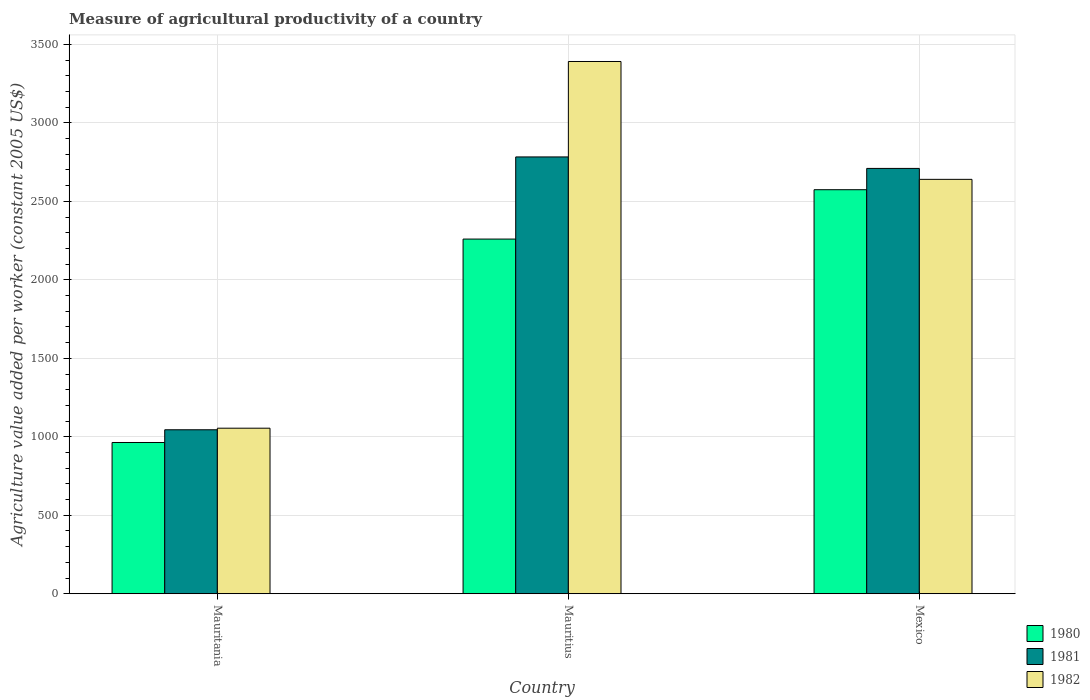How many different coloured bars are there?
Provide a short and direct response. 3. How many groups of bars are there?
Provide a short and direct response. 3. Are the number of bars per tick equal to the number of legend labels?
Your answer should be compact. Yes. What is the label of the 1st group of bars from the left?
Provide a short and direct response. Mauritania. What is the measure of agricultural productivity in 1982 in Mauritania?
Offer a very short reply. 1054.73. Across all countries, what is the maximum measure of agricultural productivity in 1981?
Give a very brief answer. 2783.08. Across all countries, what is the minimum measure of agricultural productivity in 1981?
Your answer should be very brief. 1044.71. In which country was the measure of agricultural productivity in 1981 maximum?
Give a very brief answer. Mauritius. In which country was the measure of agricultural productivity in 1980 minimum?
Your response must be concise. Mauritania. What is the total measure of agricultural productivity in 1981 in the graph?
Offer a terse response. 6537.73. What is the difference between the measure of agricultural productivity in 1981 in Mauritania and that in Mexico?
Give a very brief answer. -1665.24. What is the difference between the measure of agricultural productivity in 1982 in Mauritania and the measure of agricultural productivity in 1981 in Mexico?
Keep it short and to the point. -1655.22. What is the average measure of agricultural productivity in 1982 per country?
Offer a terse response. 2362.05. What is the difference between the measure of agricultural productivity of/in 1981 and measure of agricultural productivity of/in 1982 in Mexico?
Provide a short and direct response. 69.68. In how many countries, is the measure of agricultural productivity in 1982 greater than 500 US$?
Give a very brief answer. 3. What is the ratio of the measure of agricultural productivity in 1980 in Mauritania to that in Mauritius?
Keep it short and to the point. 0.43. Is the measure of agricultural productivity in 1981 in Mauritania less than that in Mexico?
Make the answer very short. Yes. Is the difference between the measure of agricultural productivity in 1981 in Mauritania and Mexico greater than the difference between the measure of agricultural productivity in 1982 in Mauritania and Mexico?
Make the answer very short. No. What is the difference between the highest and the second highest measure of agricultural productivity in 1982?
Offer a very short reply. 1585.54. What is the difference between the highest and the lowest measure of agricultural productivity in 1982?
Offer a terse response. 2336.44. In how many countries, is the measure of agricultural productivity in 1982 greater than the average measure of agricultural productivity in 1982 taken over all countries?
Keep it short and to the point. 2. Is the sum of the measure of agricultural productivity in 1981 in Mauritania and Mauritius greater than the maximum measure of agricultural productivity in 1982 across all countries?
Give a very brief answer. Yes. What does the 3rd bar from the left in Mauritius represents?
Offer a very short reply. 1982. How many bars are there?
Your answer should be very brief. 9. How many countries are there in the graph?
Provide a short and direct response. 3. Does the graph contain any zero values?
Your answer should be very brief. No. How many legend labels are there?
Your answer should be very brief. 3. How are the legend labels stacked?
Offer a very short reply. Vertical. What is the title of the graph?
Offer a very short reply. Measure of agricultural productivity of a country. Does "1977" appear as one of the legend labels in the graph?
Your answer should be very brief. No. What is the label or title of the X-axis?
Provide a succinct answer. Country. What is the label or title of the Y-axis?
Keep it short and to the point. Agriculture value added per worker (constant 2005 US$). What is the Agriculture value added per worker (constant 2005 US$) of 1980 in Mauritania?
Your answer should be compact. 963.64. What is the Agriculture value added per worker (constant 2005 US$) of 1981 in Mauritania?
Offer a terse response. 1044.71. What is the Agriculture value added per worker (constant 2005 US$) of 1982 in Mauritania?
Offer a terse response. 1054.73. What is the Agriculture value added per worker (constant 2005 US$) of 1980 in Mauritius?
Provide a short and direct response. 2259.73. What is the Agriculture value added per worker (constant 2005 US$) in 1981 in Mauritius?
Your answer should be very brief. 2783.08. What is the Agriculture value added per worker (constant 2005 US$) in 1982 in Mauritius?
Your answer should be very brief. 3391.17. What is the Agriculture value added per worker (constant 2005 US$) in 1980 in Mexico?
Provide a short and direct response. 2574.24. What is the Agriculture value added per worker (constant 2005 US$) of 1981 in Mexico?
Offer a very short reply. 2709.94. What is the Agriculture value added per worker (constant 2005 US$) in 1982 in Mexico?
Make the answer very short. 2640.27. Across all countries, what is the maximum Agriculture value added per worker (constant 2005 US$) of 1980?
Your answer should be compact. 2574.24. Across all countries, what is the maximum Agriculture value added per worker (constant 2005 US$) of 1981?
Ensure brevity in your answer.  2783.08. Across all countries, what is the maximum Agriculture value added per worker (constant 2005 US$) in 1982?
Provide a succinct answer. 3391.17. Across all countries, what is the minimum Agriculture value added per worker (constant 2005 US$) in 1980?
Offer a terse response. 963.64. Across all countries, what is the minimum Agriculture value added per worker (constant 2005 US$) in 1981?
Offer a terse response. 1044.71. Across all countries, what is the minimum Agriculture value added per worker (constant 2005 US$) in 1982?
Ensure brevity in your answer.  1054.73. What is the total Agriculture value added per worker (constant 2005 US$) in 1980 in the graph?
Provide a succinct answer. 5797.61. What is the total Agriculture value added per worker (constant 2005 US$) of 1981 in the graph?
Offer a terse response. 6537.73. What is the total Agriculture value added per worker (constant 2005 US$) in 1982 in the graph?
Give a very brief answer. 7086.16. What is the difference between the Agriculture value added per worker (constant 2005 US$) of 1980 in Mauritania and that in Mauritius?
Keep it short and to the point. -1296.09. What is the difference between the Agriculture value added per worker (constant 2005 US$) of 1981 in Mauritania and that in Mauritius?
Make the answer very short. -1738.38. What is the difference between the Agriculture value added per worker (constant 2005 US$) in 1982 in Mauritania and that in Mauritius?
Offer a terse response. -2336.44. What is the difference between the Agriculture value added per worker (constant 2005 US$) of 1980 in Mauritania and that in Mexico?
Provide a short and direct response. -1610.59. What is the difference between the Agriculture value added per worker (constant 2005 US$) of 1981 in Mauritania and that in Mexico?
Your response must be concise. -1665.24. What is the difference between the Agriculture value added per worker (constant 2005 US$) of 1982 in Mauritania and that in Mexico?
Your answer should be compact. -1585.54. What is the difference between the Agriculture value added per worker (constant 2005 US$) of 1980 in Mauritius and that in Mexico?
Offer a very short reply. -314.51. What is the difference between the Agriculture value added per worker (constant 2005 US$) of 1981 in Mauritius and that in Mexico?
Provide a succinct answer. 73.14. What is the difference between the Agriculture value added per worker (constant 2005 US$) in 1982 in Mauritius and that in Mexico?
Provide a succinct answer. 750.9. What is the difference between the Agriculture value added per worker (constant 2005 US$) in 1980 in Mauritania and the Agriculture value added per worker (constant 2005 US$) in 1981 in Mauritius?
Keep it short and to the point. -1819.44. What is the difference between the Agriculture value added per worker (constant 2005 US$) in 1980 in Mauritania and the Agriculture value added per worker (constant 2005 US$) in 1982 in Mauritius?
Your answer should be compact. -2427.53. What is the difference between the Agriculture value added per worker (constant 2005 US$) of 1981 in Mauritania and the Agriculture value added per worker (constant 2005 US$) of 1982 in Mauritius?
Your answer should be compact. -2346.46. What is the difference between the Agriculture value added per worker (constant 2005 US$) in 1980 in Mauritania and the Agriculture value added per worker (constant 2005 US$) in 1981 in Mexico?
Keep it short and to the point. -1746.3. What is the difference between the Agriculture value added per worker (constant 2005 US$) in 1980 in Mauritania and the Agriculture value added per worker (constant 2005 US$) in 1982 in Mexico?
Give a very brief answer. -1676.62. What is the difference between the Agriculture value added per worker (constant 2005 US$) in 1981 in Mauritania and the Agriculture value added per worker (constant 2005 US$) in 1982 in Mexico?
Provide a succinct answer. -1595.56. What is the difference between the Agriculture value added per worker (constant 2005 US$) of 1980 in Mauritius and the Agriculture value added per worker (constant 2005 US$) of 1981 in Mexico?
Make the answer very short. -450.21. What is the difference between the Agriculture value added per worker (constant 2005 US$) in 1980 in Mauritius and the Agriculture value added per worker (constant 2005 US$) in 1982 in Mexico?
Make the answer very short. -380.54. What is the difference between the Agriculture value added per worker (constant 2005 US$) in 1981 in Mauritius and the Agriculture value added per worker (constant 2005 US$) in 1982 in Mexico?
Ensure brevity in your answer.  142.82. What is the average Agriculture value added per worker (constant 2005 US$) in 1980 per country?
Your response must be concise. 1932.54. What is the average Agriculture value added per worker (constant 2005 US$) in 1981 per country?
Keep it short and to the point. 2179.24. What is the average Agriculture value added per worker (constant 2005 US$) of 1982 per country?
Offer a very short reply. 2362.05. What is the difference between the Agriculture value added per worker (constant 2005 US$) in 1980 and Agriculture value added per worker (constant 2005 US$) in 1981 in Mauritania?
Give a very brief answer. -81.06. What is the difference between the Agriculture value added per worker (constant 2005 US$) of 1980 and Agriculture value added per worker (constant 2005 US$) of 1982 in Mauritania?
Offer a terse response. -91.08. What is the difference between the Agriculture value added per worker (constant 2005 US$) of 1981 and Agriculture value added per worker (constant 2005 US$) of 1982 in Mauritania?
Provide a succinct answer. -10.02. What is the difference between the Agriculture value added per worker (constant 2005 US$) of 1980 and Agriculture value added per worker (constant 2005 US$) of 1981 in Mauritius?
Your response must be concise. -523.35. What is the difference between the Agriculture value added per worker (constant 2005 US$) in 1980 and Agriculture value added per worker (constant 2005 US$) in 1982 in Mauritius?
Your answer should be compact. -1131.44. What is the difference between the Agriculture value added per worker (constant 2005 US$) of 1981 and Agriculture value added per worker (constant 2005 US$) of 1982 in Mauritius?
Your answer should be very brief. -608.09. What is the difference between the Agriculture value added per worker (constant 2005 US$) in 1980 and Agriculture value added per worker (constant 2005 US$) in 1981 in Mexico?
Your response must be concise. -135.71. What is the difference between the Agriculture value added per worker (constant 2005 US$) of 1980 and Agriculture value added per worker (constant 2005 US$) of 1982 in Mexico?
Your answer should be very brief. -66.03. What is the difference between the Agriculture value added per worker (constant 2005 US$) of 1981 and Agriculture value added per worker (constant 2005 US$) of 1982 in Mexico?
Make the answer very short. 69.68. What is the ratio of the Agriculture value added per worker (constant 2005 US$) of 1980 in Mauritania to that in Mauritius?
Offer a very short reply. 0.43. What is the ratio of the Agriculture value added per worker (constant 2005 US$) of 1981 in Mauritania to that in Mauritius?
Make the answer very short. 0.38. What is the ratio of the Agriculture value added per worker (constant 2005 US$) of 1982 in Mauritania to that in Mauritius?
Your answer should be compact. 0.31. What is the ratio of the Agriculture value added per worker (constant 2005 US$) of 1980 in Mauritania to that in Mexico?
Offer a very short reply. 0.37. What is the ratio of the Agriculture value added per worker (constant 2005 US$) in 1981 in Mauritania to that in Mexico?
Provide a short and direct response. 0.39. What is the ratio of the Agriculture value added per worker (constant 2005 US$) in 1982 in Mauritania to that in Mexico?
Give a very brief answer. 0.4. What is the ratio of the Agriculture value added per worker (constant 2005 US$) in 1980 in Mauritius to that in Mexico?
Keep it short and to the point. 0.88. What is the ratio of the Agriculture value added per worker (constant 2005 US$) in 1981 in Mauritius to that in Mexico?
Keep it short and to the point. 1.03. What is the ratio of the Agriculture value added per worker (constant 2005 US$) of 1982 in Mauritius to that in Mexico?
Make the answer very short. 1.28. What is the difference between the highest and the second highest Agriculture value added per worker (constant 2005 US$) in 1980?
Keep it short and to the point. 314.51. What is the difference between the highest and the second highest Agriculture value added per worker (constant 2005 US$) in 1981?
Your answer should be compact. 73.14. What is the difference between the highest and the second highest Agriculture value added per worker (constant 2005 US$) in 1982?
Give a very brief answer. 750.9. What is the difference between the highest and the lowest Agriculture value added per worker (constant 2005 US$) in 1980?
Keep it short and to the point. 1610.59. What is the difference between the highest and the lowest Agriculture value added per worker (constant 2005 US$) in 1981?
Provide a short and direct response. 1738.38. What is the difference between the highest and the lowest Agriculture value added per worker (constant 2005 US$) of 1982?
Offer a terse response. 2336.44. 